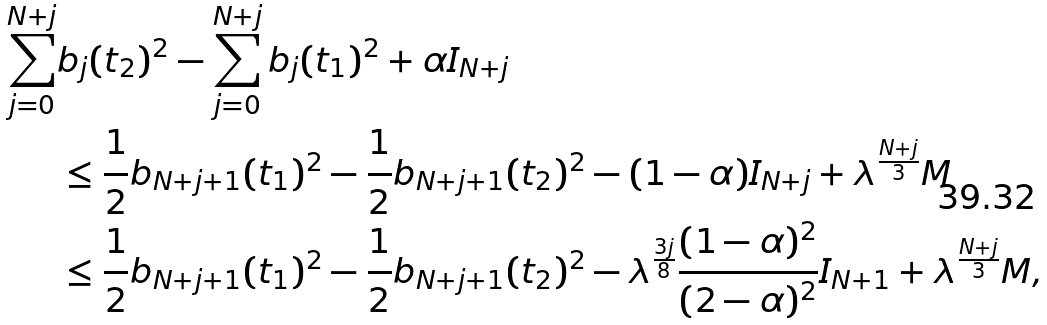Convert formula to latex. <formula><loc_0><loc_0><loc_500><loc_500>\sum _ { j = 0 } ^ { N + j } & b _ { j } ( t _ { 2 } ) ^ { 2 } - \sum _ { j = 0 } ^ { N + j } b _ { j } ( t _ { 1 } ) ^ { 2 } + \alpha I _ { N + j } \\ & \leq \frac { 1 } { 2 } b _ { N + j + 1 } ( t _ { 1 } ) ^ { 2 } - \frac { 1 } { 2 } b _ { N + j + 1 } ( t _ { 2 } ) ^ { 2 } - ( 1 - \alpha ) I _ { N + j } + \lambda ^ { \frac { N + j } { 3 } } M \\ & \leq \frac { 1 } { 2 } b _ { N + j + 1 } ( t _ { 1 } ) ^ { 2 } - \frac { 1 } { 2 } b _ { N + j + 1 } ( t _ { 2 } ) ^ { 2 } - \lambda ^ { \frac { 3 j } { 8 } } \frac { ( 1 - \alpha ) ^ { 2 } } { ( 2 - \alpha ) ^ { 2 } } I _ { N + 1 } + \lambda ^ { \frac { N + j } { 3 } } M ,</formula> 